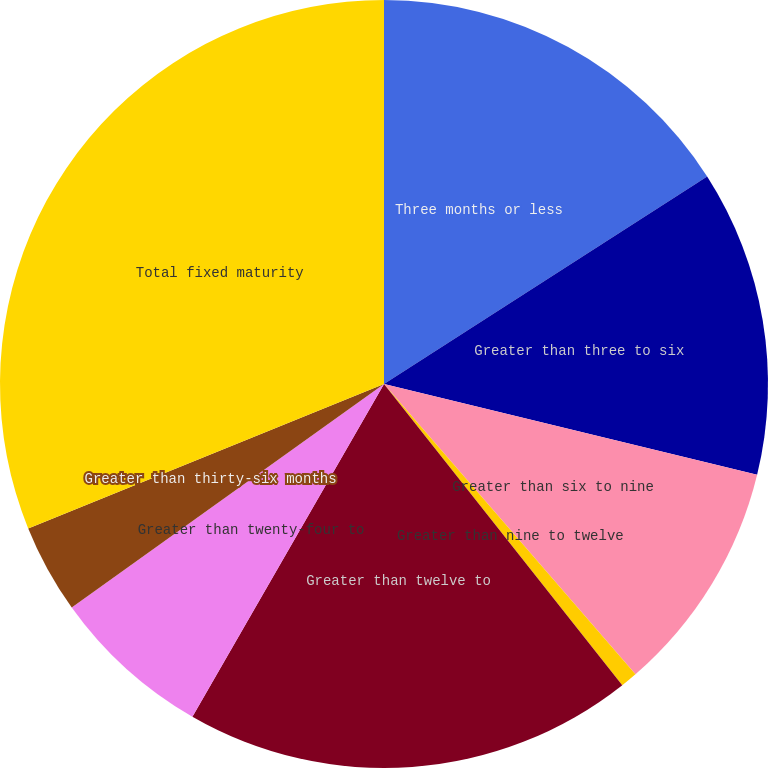Convert chart. <chart><loc_0><loc_0><loc_500><loc_500><pie_chart><fcel>Three months or less<fcel>Greater than three to six<fcel>Greater than six to nine<fcel>Greater than nine to twelve<fcel>Greater than twelve to<fcel>Greater than twenty-four to<fcel>Greater than thirty-six months<fcel>Total fixed maturity<nl><fcel>15.92%<fcel>12.88%<fcel>9.84%<fcel>0.71%<fcel>18.97%<fcel>6.8%<fcel>3.75%<fcel>31.14%<nl></chart> 